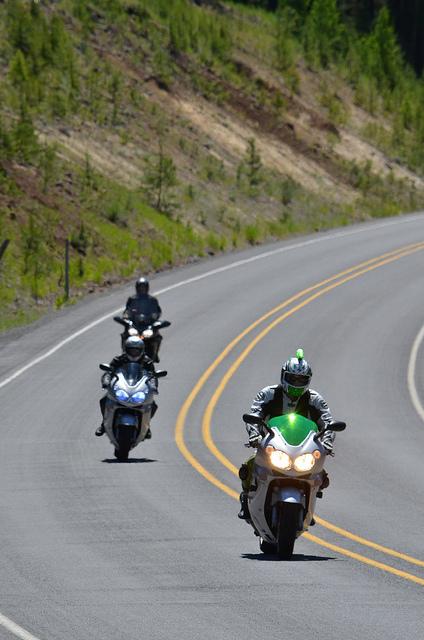Is the line in the road solid?
Short answer required. Yes. Are the people racing?
Answer briefly. No. How many lights are on the front of each motorcycle?
Quick response, please. 2. 